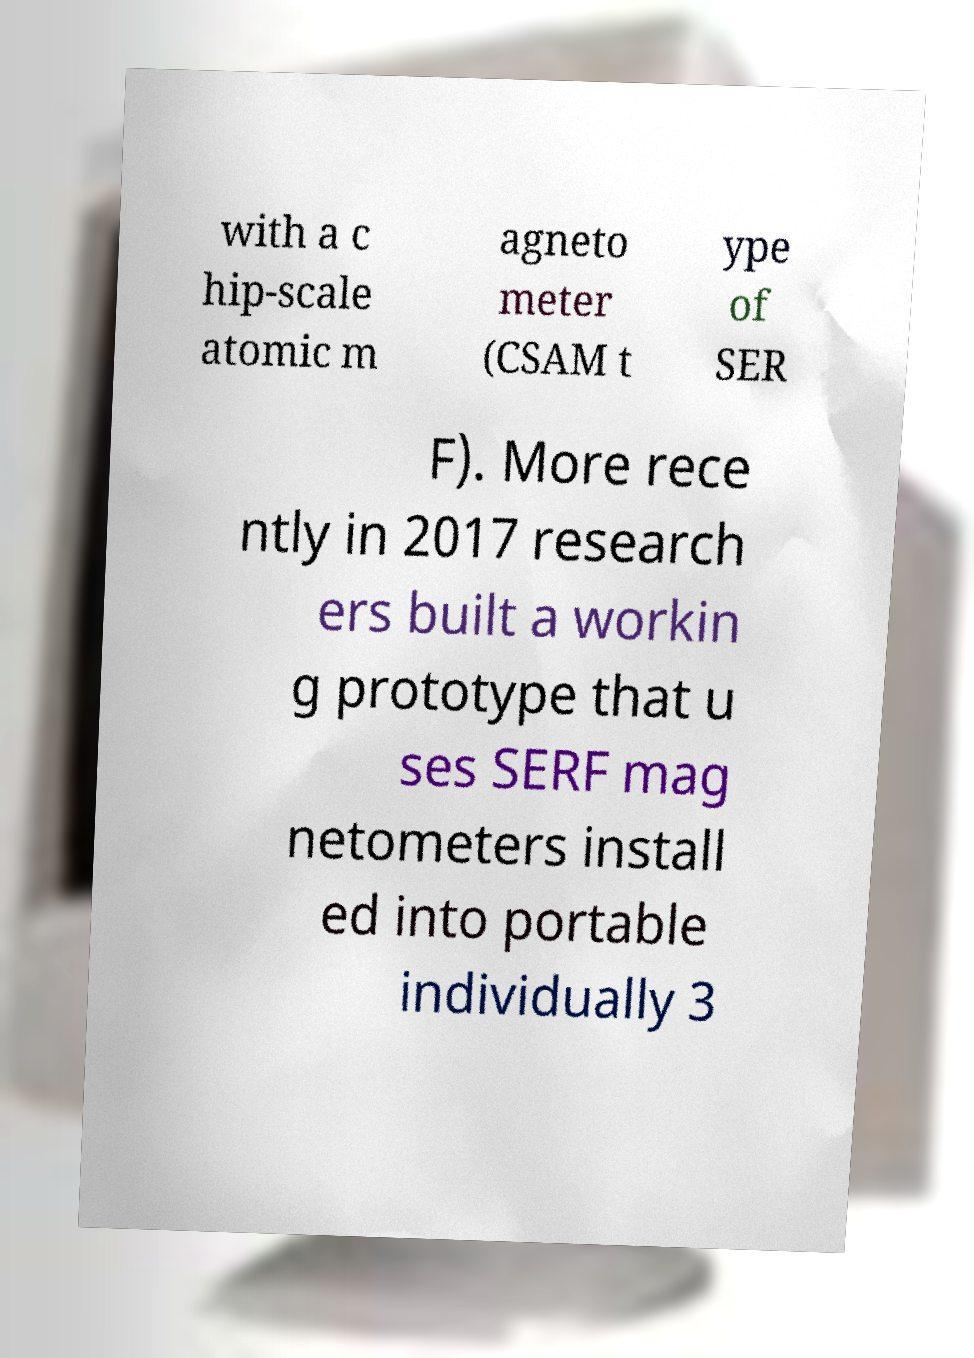What messages or text are displayed in this image? I need them in a readable, typed format. with a c hip-scale atomic m agneto meter (CSAM t ype of SER F). More rece ntly in 2017 research ers built a workin g prototype that u ses SERF mag netometers install ed into portable individually 3 